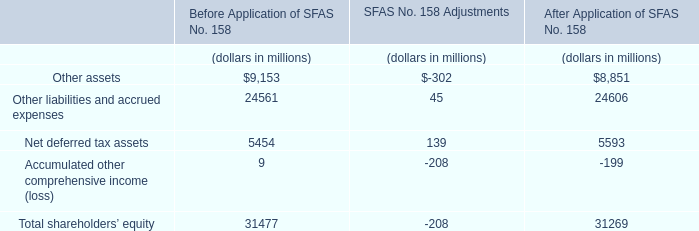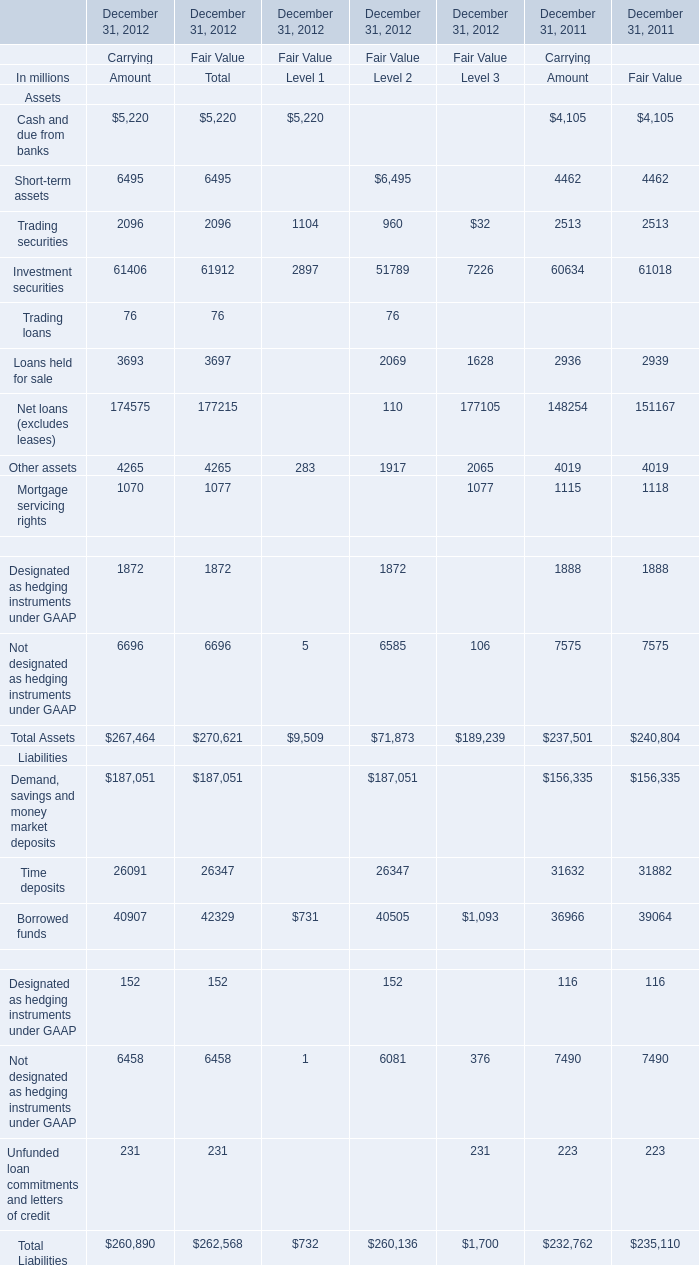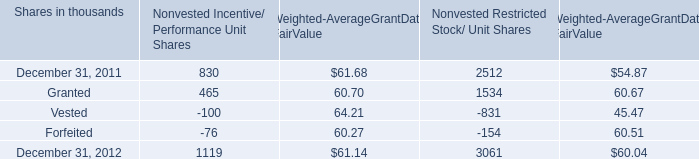what was the average cost per unit for the weighted-average grant-date fair value of incentive/ performance unit share awards and restricted stock/unit awards granted in 2012 , 2011 and 2010? 
Computations: (((60.68 + 63.25) + 54.59) / 3)
Answer: 59.50667. 